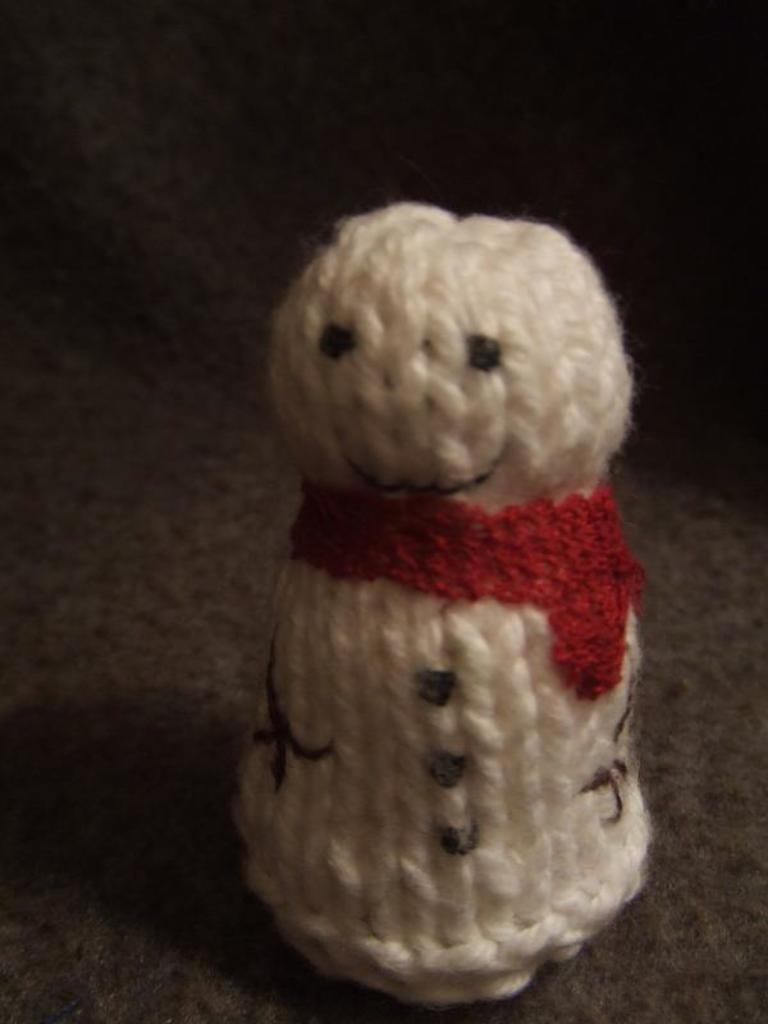What type of toy is in the image? There is a woolen toy in the image. Can you describe the colors of the toy? The toy is white and red in color. What disease is the toy trying to cure in the image? There is no indication in the image that the toy is trying to cure any disease, as it is a woolen toy and not a medical treatment. 